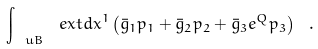<formula> <loc_0><loc_0><loc_500><loc_500>\int _ { \ u B } \ e x t d x ^ { 1 } \left ( \bar { g } _ { 1 } p _ { 1 } + \bar { g } _ { 2 } p _ { 2 } + \bar { g } _ { 3 } e ^ { Q } p _ { 3 } \right ) \ .</formula> 